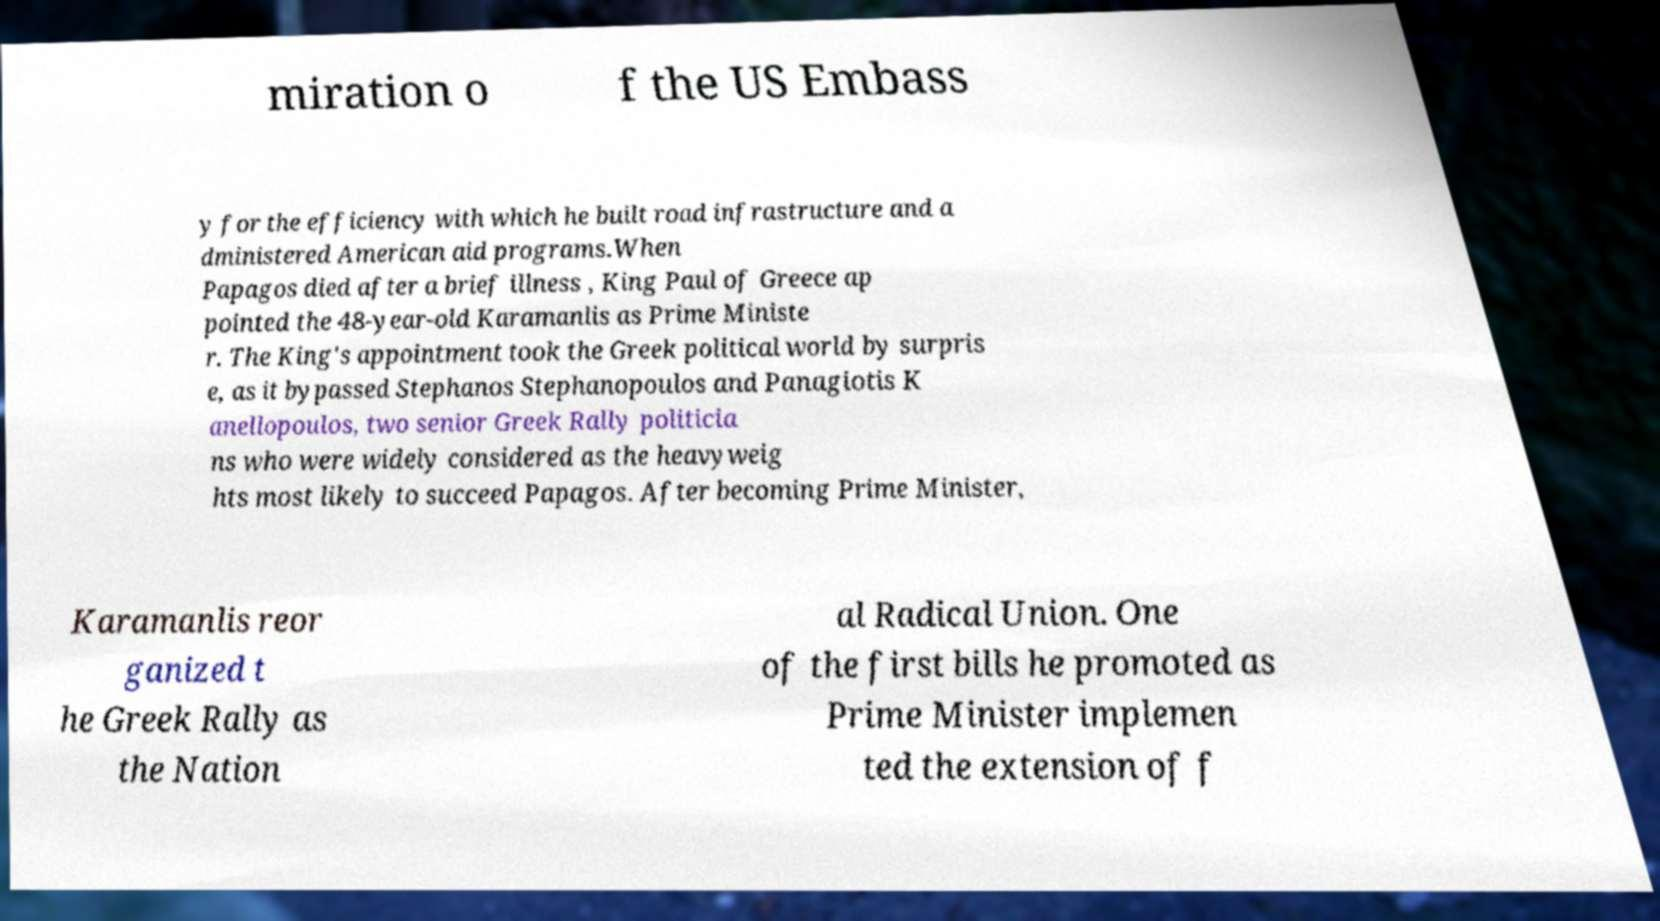What messages or text are displayed in this image? I need them in a readable, typed format. miration o f the US Embass y for the efficiency with which he built road infrastructure and a dministered American aid programs.When Papagos died after a brief illness , King Paul of Greece ap pointed the 48-year-old Karamanlis as Prime Ministe r. The King's appointment took the Greek political world by surpris e, as it bypassed Stephanos Stephanopoulos and Panagiotis K anellopoulos, two senior Greek Rally politicia ns who were widely considered as the heavyweig hts most likely to succeed Papagos. After becoming Prime Minister, Karamanlis reor ganized t he Greek Rally as the Nation al Radical Union. One of the first bills he promoted as Prime Minister implemen ted the extension of f 